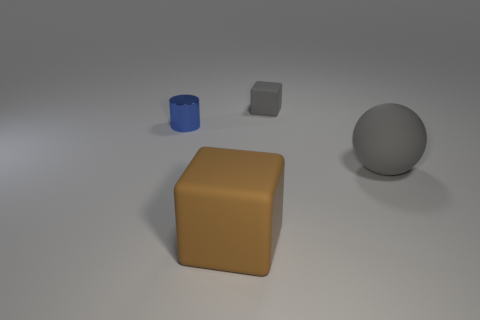Is there any other thing that has the same material as the tiny blue thing?
Offer a terse response. No. There is a cube that is the same color as the big rubber sphere; what size is it?
Your answer should be compact. Small. How many large matte things are on the left side of the sphere and on the right side of the brown block?
Offer a terse response. 0. There is another rubber thing that is the same shape as the small gray rubber object; what size is it?
Give a very brief answer. Large. What number of brown matte things are on the right side of the large cube left of the gray matte object in front of the small matte object?
Ensure brevity in your answer.  0. What is the color of the large matte object that is behind the object in front of the big gray sphere?
Your answer should be very brief. Gray. What number of other objects are there of the same material as the gray ball?
Your answer should be very brief. 2. There is a small object that is on the left side of the big block; what number of large matte spheres are on the right side of it?
Offer a terse response. 1. Is there anything else that has the same shape as the blue metal thing?
Your answer should be compact. No. Is the color of the large object on the right side of the big rubber cube the same as the tiny thing that is right of the big brown matte object?
Provide a succinct answer. Yes. 